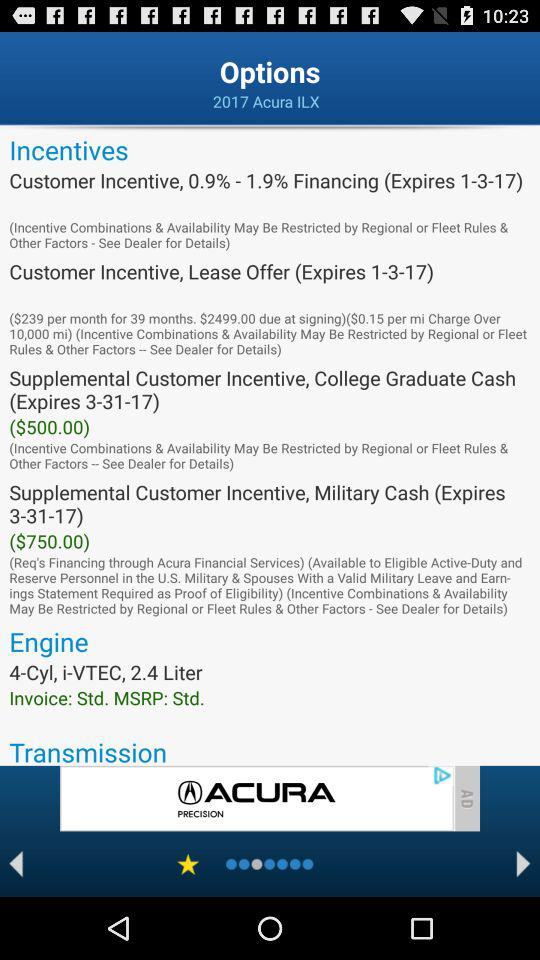What is the type of engine? The type of engine is a 4-cylinder. 